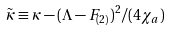Convert formula to latex. <formula><loc_0><loc_0><loc_500><loc_500>\tilde { \kappa } \equiv \kappa - ( \Lambda - F _ { ( 2 ) } ) ^ { 2 } / ( 4 \chi _ { a } )</formula> 